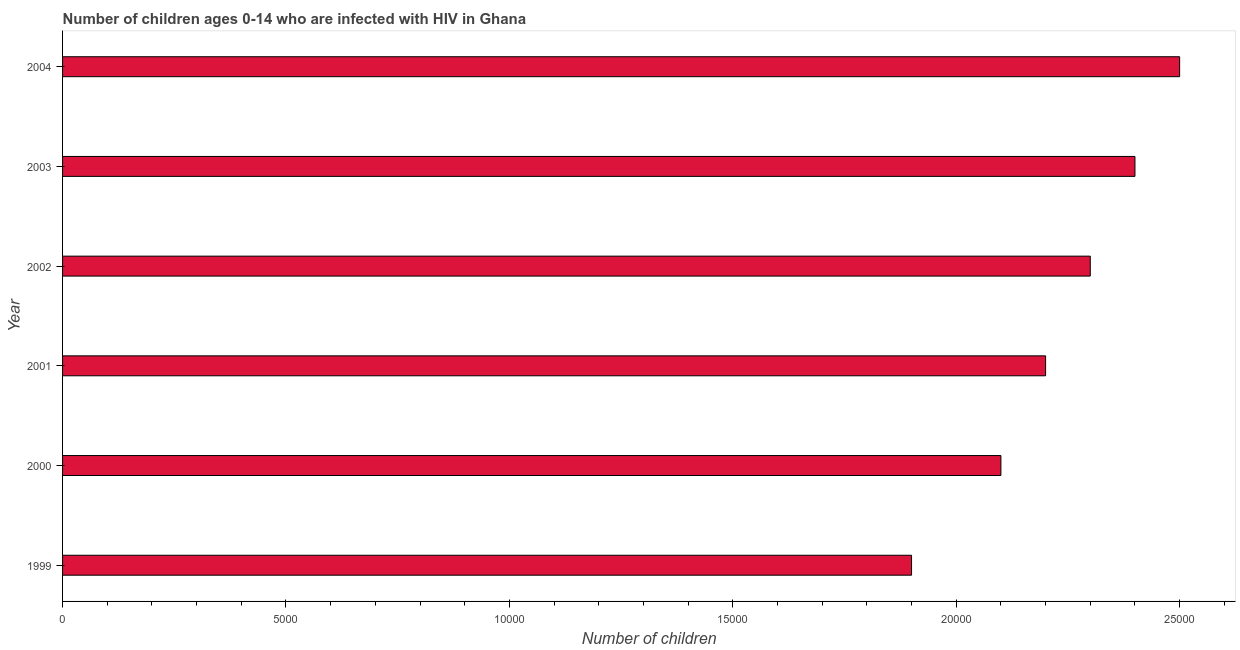What is the title of the graph?
Give a very brief answer. Number of children ages 0-14 who are infected with HIV in Ghana. What is the label or title of the X-axis?
Your answer should be very brief. Number of children. What is the label or title of the Y-axis?
Give a very brief answer. Year. What is the number of children living with hiv in 2001?
Offer a very short reply. 2.20e+04. Across all years, what is the maximum number of children living with hiv?
Ensure brevity in your answer.  2.50e+04. Across all years, what is the minimum number of children living with hiv?
Give a very brief answer. 1.90e+04. What is the sum of the number of children living with hiv?
Offer a terse response. 1.34e+05. What is the difference between the number of children living with hiv in 1999 and 2004?
Offer a very short reply. -6000. What is the average number of children living with hiv per year?
Keep it short and to the point. 2.23e+04. What is the median number of children living with hiv?
Offer a very short reply. 2.25e+04. In how many years, is the number of children living with hiv greater than 10000 ?
Give a very brief answer. 6. What is the ratio of the number of children living with hiv in 1999 to that in 2003?
Your answer should be very brief. 0.79. What is the difference between the highest and the lowest number of children living with hiv?
Provide a succinct answer. 6000. How many bars are there?
Make the answer very short. 6. Are all the bars in the graph horizontal?
Give a very brief answer. Yes. How many years are there in the graph?
Your response must be concise. 6. What is the Number of children of 1999?
Keep it short and to the point. 1.90e+04. What is the Number of children in 2000?
Your answer should be compact. 2.10e+04. What is the Number of children in 2001?
Ensure brevity in your answer.  2.20e+04. What is the Number of children in 2002?
Give a very brief answer. 2.30e+04. What is the Number of children of 2003?
Provide a short and direct response. 2.40e+04. What is the Number of children in 2004?
Your answer should be compact. 2.50e+04. What is the difference between the Number of children in 1999 and 2000?
Ensure brevity in your answer.  -2000. What is the difference between the Number of children in 1999 and 2001?
Give a very brief answer. -3000. What is the difference between the Number of children in 1999 and 2002?
Make the answer very short. -4000. What is the difference between the Number of children in 1999 and 2003?
Keep it short and to the point. -5000. What is the difference between the Number of children in 1999 and 2004?
Your answer should be very brief. -6000. What is the difference between the Number of children in 2000 and 2001?
Your answer should be compact. -1000. What is the difference between the Number of children in 2000 and 2002?
Your answer should be compact. -2000. What is the difference between the Number of children in 2000 and 2003?
Offer a very short reply. -3000. What is the difference between the Number of children in 2000 and 2004?
Your response must be concise. -4000. What is the difference between the Number of children in 2001 and 2002?
Your answer should be compact. -1000. What is the difference between the Number of children in 2001 and 2003?
Your response must be concise. -2000. What is the difference between the Number of children in 2001 and 2004?
Provide a short and direct response. -3000. What is the difference between the Number of children in 2002 and 2003?
Give a very brief answer. -1000. What is the difference between the Number of children in 2002 and 2004?
Offer a terse response. -2000. What is the difference between the Number of children in 2003 and 2004?
Your response must be concise. -1000. What is the ratio of the Number of children in 1999 to that in 2000?
Ensure brevity in your answer.  0.91. What is the ratio of the Number of children in 1999 to that in 2001?
Provide a succinct answer. 0.86. What is the ratio of the Number of children in 1999 to that in 2002?
Offer a very short reply. 0.83. What is the ratio of the Number of children in 1999 to that in 2003?
Provide a succinct answer. 0.79. What is the ratio of the Number of children in 1999 to that in 2004?
Your response must be concise. 0.76. What is the ratio of the Number of children in 2000 to that in 2001?
Ensure brevity in your answer.  0.95. What is the ratio of the Number of children in 2000 to that in 2002?
Your answer should be very brief. 0.91. What is the ratio of the Number of children in 2000 to that in 2004?
Offer a very short reply. 0.84. What is the ratio of the Number of children in 2001 to that in 2003?
Provide a succinct answer. 0.92. What is the ratio of the Number of children in 2001 to that in 2004?
Ensure brevity in your answer.  0.88. What is the ratio of the Number of children in 2002 to that in 2003?
Your response must be concise. 0.96. What is the ratio of the Number of children in 2002 to that in 2004?
Keep it short and to the point. 0.92. What is the ratio of the Number of children in 2003 to that in 2004?
Your answer should be very brief. 0.96. 